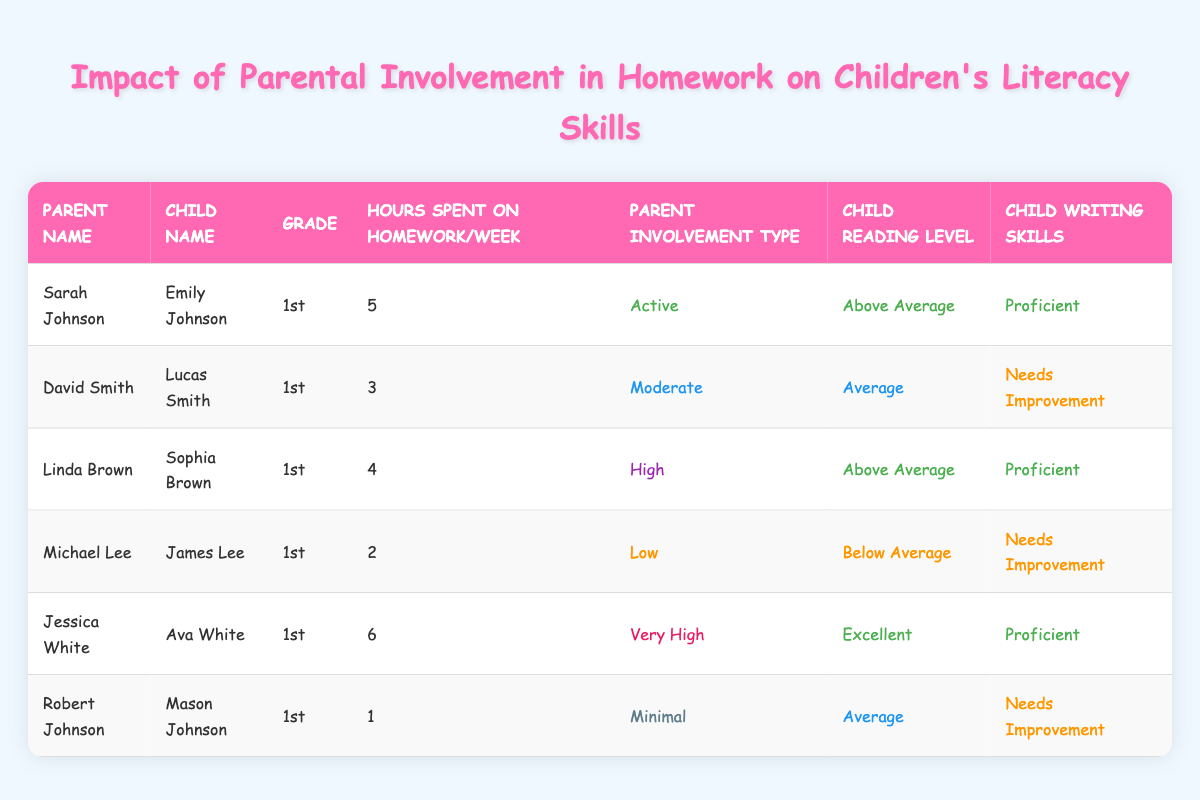What is the reading level of Ava White? Ava White's reading level can be found in the "Child Reading Level" column. If we look at the row for Ava White, we see that her reading level is "Excellent."
Answer: Excellent How many hours per week does Sarah Johnson spend on homework with Emily? To answer this, we refer to the row for Sarah Johnson, where the "Hours Spent on Homework/Week" column shows the value of 5 hours.
Answer: 5 Which child has the highest reading level? We need to compare the "Child Reading Level" values for all children. The highest reading levels present in the table are "Excellent" and "Above Average." Since Jessica White's child, Ava, has an "Excellent" level, she is the one with the highest reading level.
Answer: Ava White Is there a correlation between hours spent on homework and children's writing skills? To check this, we need to analyze the data. Looking at the table, as hours spent on homework increases, children's writing skills improve from "Needs Improvement" to "Proficient." Specifically, Ava White (6 hours) and Emily Johnson (5 hours) both demonstrate "Proficient" writing skills. However, there are exceptions. The total conclusion cannot be definitively established as we do not have enough data points for all variations.
Answer: Yes, generally more hours correlate with better writing skills, but not in all cases What is the average number of hours spent on homework per week by the parents? We will sum the hours spent on homework by all children and then divide by the number of children. The total hours are (5 + 3 + 4 + 2 + 6 + 1) = 21. As there are 6 children, the average is 21/6 = 3.5.
Answer: 3.5 